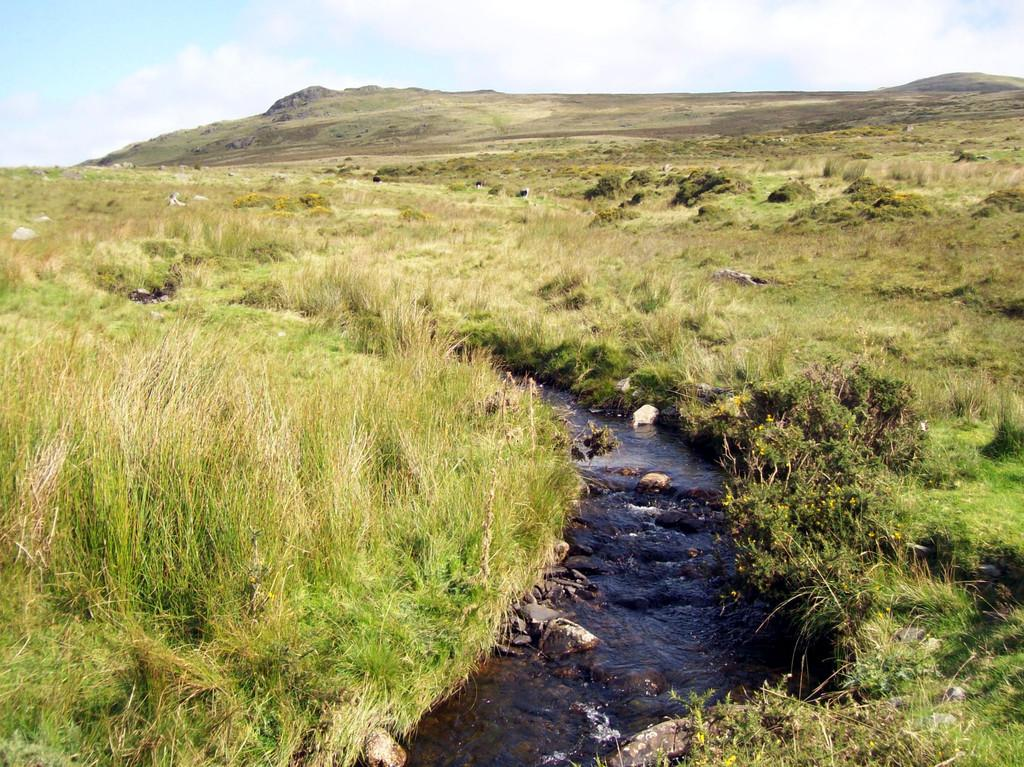What is the primary element in the image? There is water in the image. What can be seen within the water? There are rocks in the water. What type of vegetation is visible in the image? There is grass visible in the image. What is visible in the background of the image? There is a mountain and the sky visible in the background of the image. How many laborers can be seen working on the mountain in the image? There are no laborers present in the image; it only features water, rocks, grass, a mountain, and the sky. What type of frog can be seen hopping on the grass in the image? There are no frogs present in the image; it only features water, rocks, grass, a mountain, and the sky. 